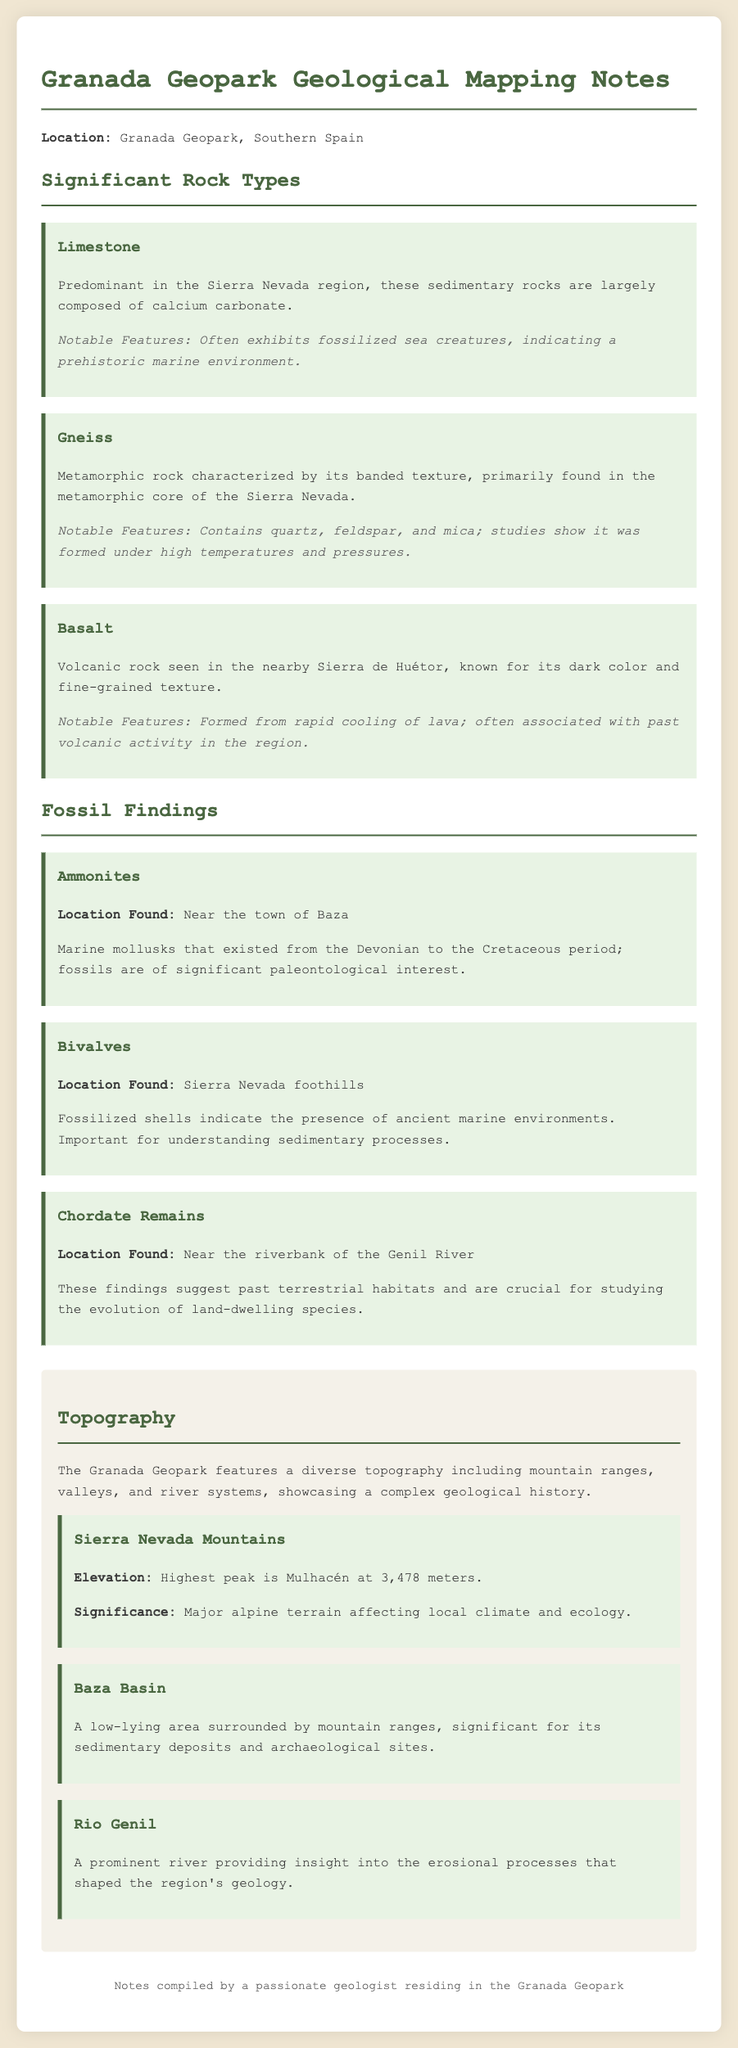What is the predominant rock type in Sierra Nevada? The document states that Limestone is predominant in the Sierra Nevada region.
Answer: Limestone What notable feature do the gneiss rocks exhibit? The significant feature of gneiss mentioned in the document is its banded texture.
Answer: Banded texture What types of fossils were found near the town of Baza? The document notes that Ammonites were found near Baza.
Answer: Ammonites What is the elevation of the highest peak in the Sierra Nevada? The document specifies the elevation of the highest peak, Mulhacén, as 3,478 meters.
Answer: 3,478 meters Which river is mentioned in the document as providing insight into erosional processes? The Rio Genil is the river noted for its role in understanding erosional processes.
Answer: Rio Genil What geological setting characterizes the Baza Basin? The document describes the Baza Basin as a low-lying area surrounded by mountain ranges.
Answer: Low-lying area What is the primary composition of limestone mentioned in the notes? Limestone is largely composed of calcium carbonate, as stated in the document.
Answer: Calcium carbonate How are bivalves significant to the geological understanding of the area? The document explains that fossilized bivalves indicate ancient marine environments, important for understanding sedimentary processes.
Answer: Ancient marine environments What type of rock is characteristic of past volcanic activity in the region? The document identifies Basalt as the volcanic rock associated with past volcanic activity.
Answer: Basalt 